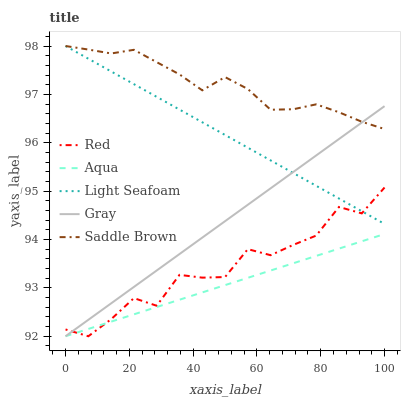Does Aqua have the minimum area under the curve?
Answer yes or no. Yes. Does Saddle Brown have the maximum area under the curve?
Answer yes or no. Yes. Does Light Seafoam have the minimum area under the curve?
Answer yes or no. No. Does Light Seafoam have the maximum area under the curve?
Answer yes or no. No. Is Aqua the smoothest?
Answer yes or no. Yes. Is Red the roughest?
Answer yes or no. Yes. Is Light Seafoam the smoothest?
Answer yes or no. No. Is Light Seafoam the roughest?
Answer yes or no. No. Does Gray have the lowest value?
Answer yes or no. Yes. Does Light Seafoam have the lowest value?
Answer yes or no. No. Does Saddle Brown have the highest value?
Answer yes or no. Yes. Does Aqua have the highest value?
Answer yes or no. No. Is Red less than Saddle Brown?
Answer yes or no. Yes. Is Saddle Brown greater than Aqua?
Answer yes or no. Yes. Does Aqua intersect Red?
Answer yes or no. Yes. Is Aqua less than Red?
Answer yes or no. No. Is Aqua greater than Red?
Answer yes or no. No. Does Red intersect Saddle Brown?
Answer yes or no. No. 